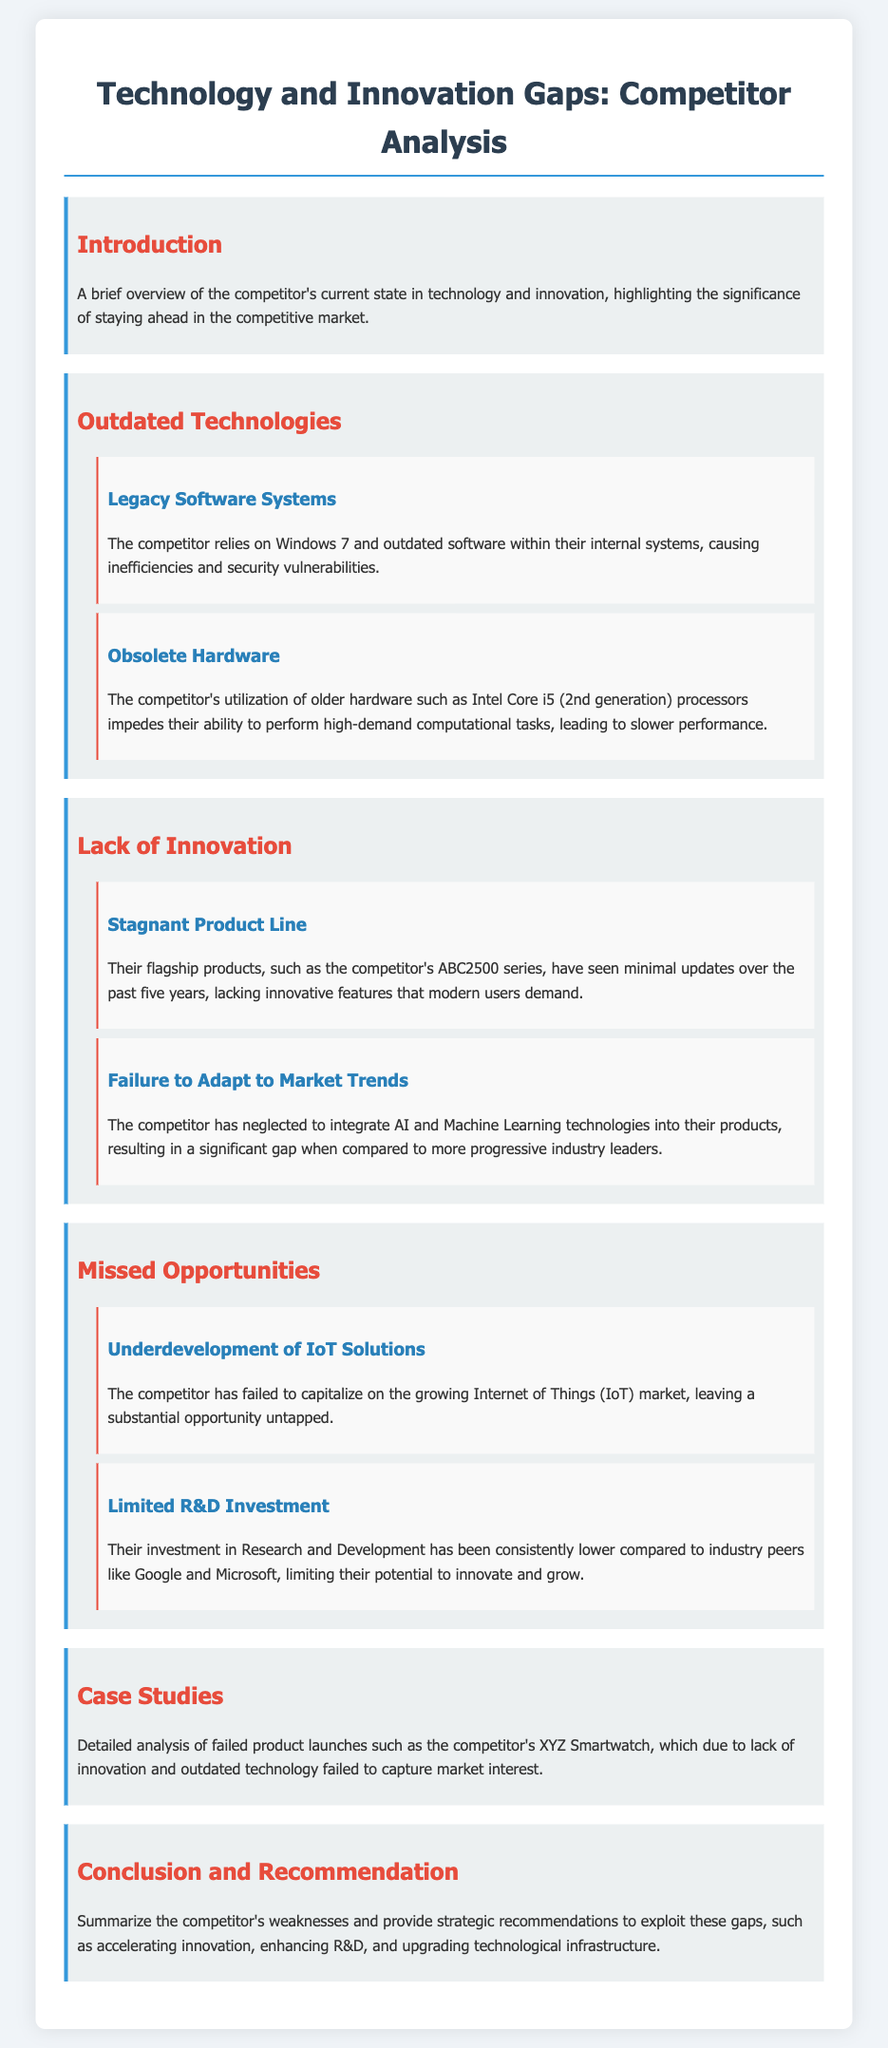What outdated software does the competitor rely on? The document states that the competitor relies on Windows 7 within their internal systems, which is an outdated software.
Answer: Windows 7 What type of hardware is mentioned as obsolete? The document mentions the utilization of older hardware such as Intel Core i5 (2nd generation) processors as obsolete.
Answer: Intel Core i5 (2nd generation) How long has it been since the competitor's flagship products saw updates? The document indicates that the competitor's flagship products have seen minimal updates over the past five years.
Answer: Five years What technology has the competitor failed to integrate into their products? The document mentions that the competitor has neglected to integrate AI and Machine Learning technologies into their products.
Answer: AI and Machine Learning What market has the competitor failed to capitalize on? According to the document, the competitor has failed to capitalize on the growing Internet of Things (IoT) market.
Answer: Internet of Things (IoT) How does the competitor's R&D investment compare to industry peers? The document states that their investment in Research and Development has been consistently lower compared to industry peers like Google and Microsoft.
Answer: Lower Which product is highlighted as a case study of failure? The document specifically mentions the XYZ Smartwatch as a failed product launch.
Answer: XYZ Smartwatch What is a strategic recommendation provided in the conclusion? The document suggests accelerating innovation as a strategic recommendation to exploit gaps in the competitor's offerings.
Answer: Accelerating innovation What is the main theme of the document? The document focuses on reviewing outdated technologies, lack of innovation, and missed opportunities in product development within the competitor's offerings.
Answer: Technology and Innovation Gaps 